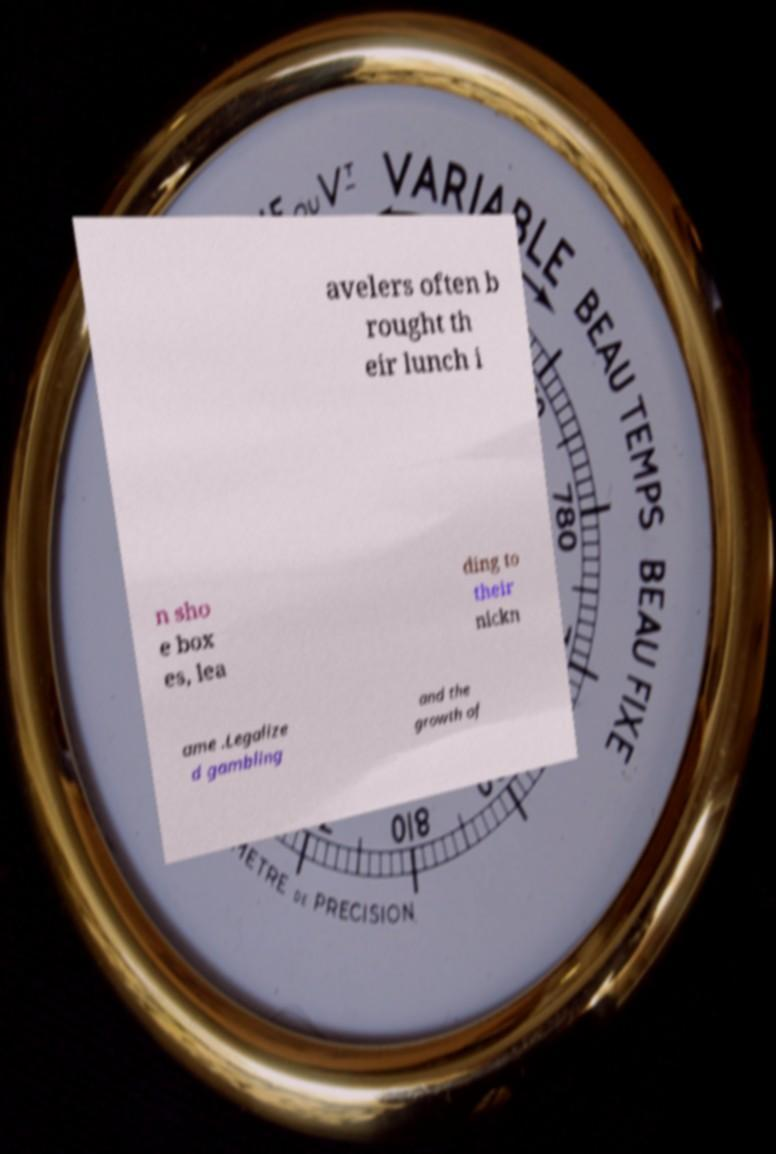Could you assist in decoding the text presented in this image and type it out clearly? avelers often b rought th eir lunch i n sho e box es, lea ding to their nickn ame .Legalize d gambling and the growth of 